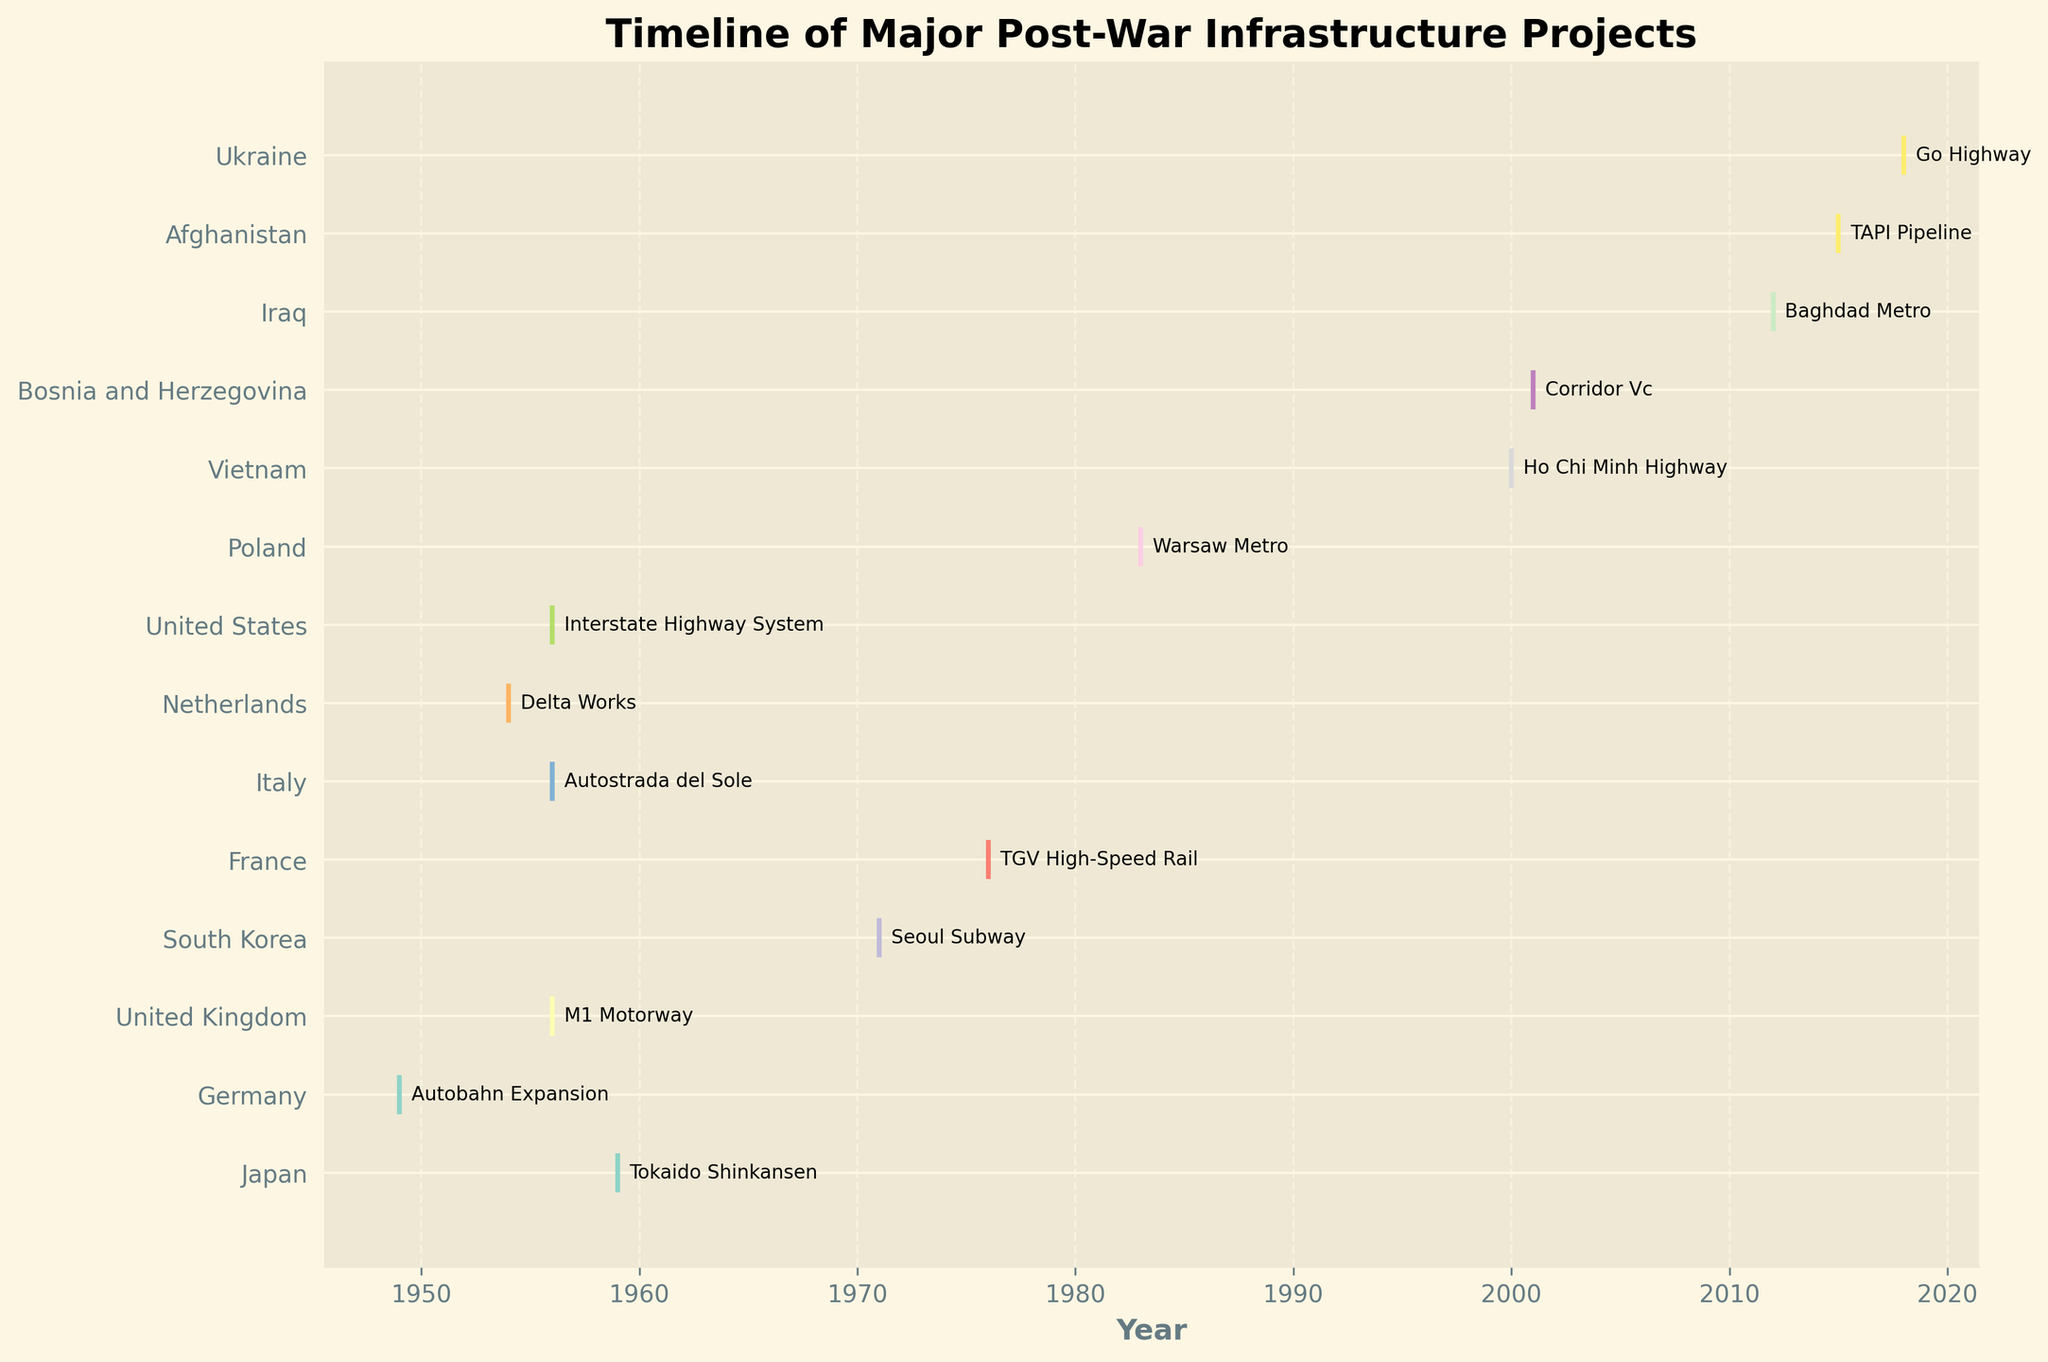What is the title of the figure? The title can be found at the top of the figure. It reads "Timeline of Major Post-War Infrastructure Projects".
Answer: Timeline of Major Post-War Infrastructure Projects Which country initiated the Tokaido Shinkansen project and in what year? By locating the Tokaido Shinkansen project annotation in the figure, it is next to Japan at the year 1959.
Answer: Japan, 1959 How many countries have their projects represented in the figure? By counting the number of unique country labels on the y-axis, there are 14 countries represented.
Answer: 14 Which projects were initiated in 1956? By observing the year 1956 on the x-axis and following it to labeled project annotations, the M1 Motorway, Autostrada del Sole, and the Interstate Highway System were initiated.
Answer: M1 Motorway, Autostrada del Sole, Interstate Highway System What is the latest project included in the timeline and which country initiated it? The latest project can be found by looking at the farthest right point on the x-axis, which is the Go Highway in 2018, initiated by Ukraine.
Answer: Go Highway, Ukraine Which countries started their major infrastructure projects in the 21st century? By identifying projects marked from the year 2000 onwards, countries with such projects are Vietnam (Ho Chi Minh Highway, 2000), Bosnia and Herzegovina (Corridor Vc, 2001), Iraq (Baghdad Metro, 2012), Afghanistan (TAPI Pipeline, 2015), and Ukraine (Go Highway, 2018).
Answer: Vietnam, Bosnia and Herzegovina, Iraq, Afghanistan, Ukraine When comparing Germany and Japan, which country initiated its major project earlier? By locating the years for Germany’s Autobahn Expansion and Japan’s Tokaido Shinkansen, Germany started in 1949 while Japan started in 1959.
Answer: Germany What is the average year in which major projects were initiated across all countries represented in the figure? Adding all the years (1959, 1949, 1956, 1971, 1976, 1956, 1954, 1956, 1983, 2000, 2001, 2012, 2015, 2018) and dividing by the number of countries (14) gives (1949+1954+1956+1956+1956+1959+1971+1976+1983+2000+2001+2012+2015+2018)/14 ≈ 1971.07, rounding gives 1971.
Answer: 1971 Which project took place the closest in time to the Autobahn Expansion (1949)? By identifying the year closest to 1949 from other projects, the Delta Works in the Netherlands began in 1954, which is the closest to 1949.
Answer: Delta Works 